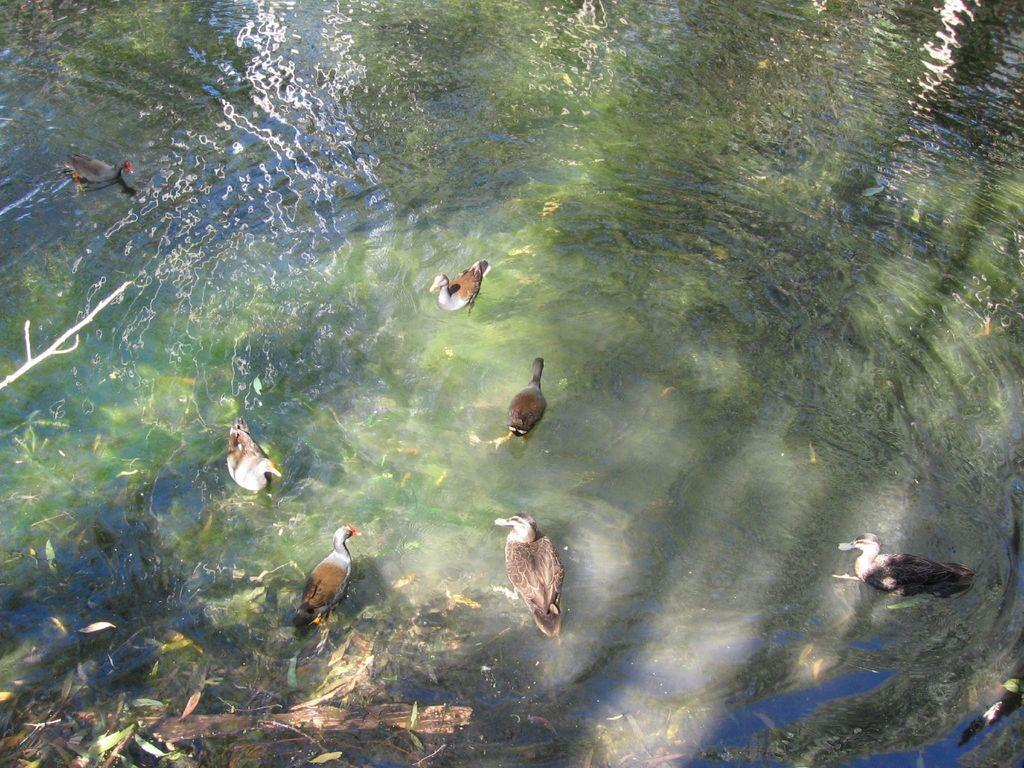What type of animals can be seen in the image? There are birds in the image. What is the primary element in which the birds are situated? The birds are situated in water. What type of vegetation is present in the image? Leaves are present in the image. What is the name of the skate that the birds are riding in the image? There are no skates present in the image, and the birds are not riding any skates. 